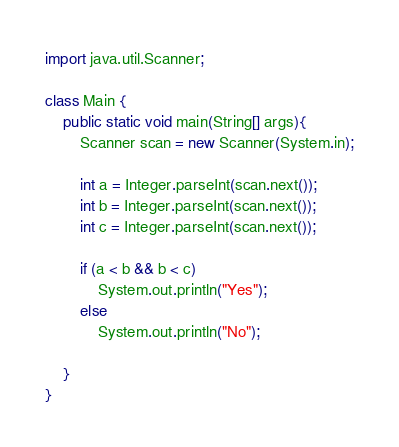Convert code to text. <code><loc_0><loc_0><loc_500><loc_500><_Java_>import java.util.Scanner;

class Main {
    public static void main(String[] args){
        Scanner scan = new Scanner(System.in);

        int a = Integer.parseInt(scan.next());
        int b = Integer.parseInt(scan.next());
        int c = Integer.parseInt(scan.next());

        if (a < b && b < c)
            System.out.println("Yes");
        else
            System.out.println("No");

    }
}</code> 